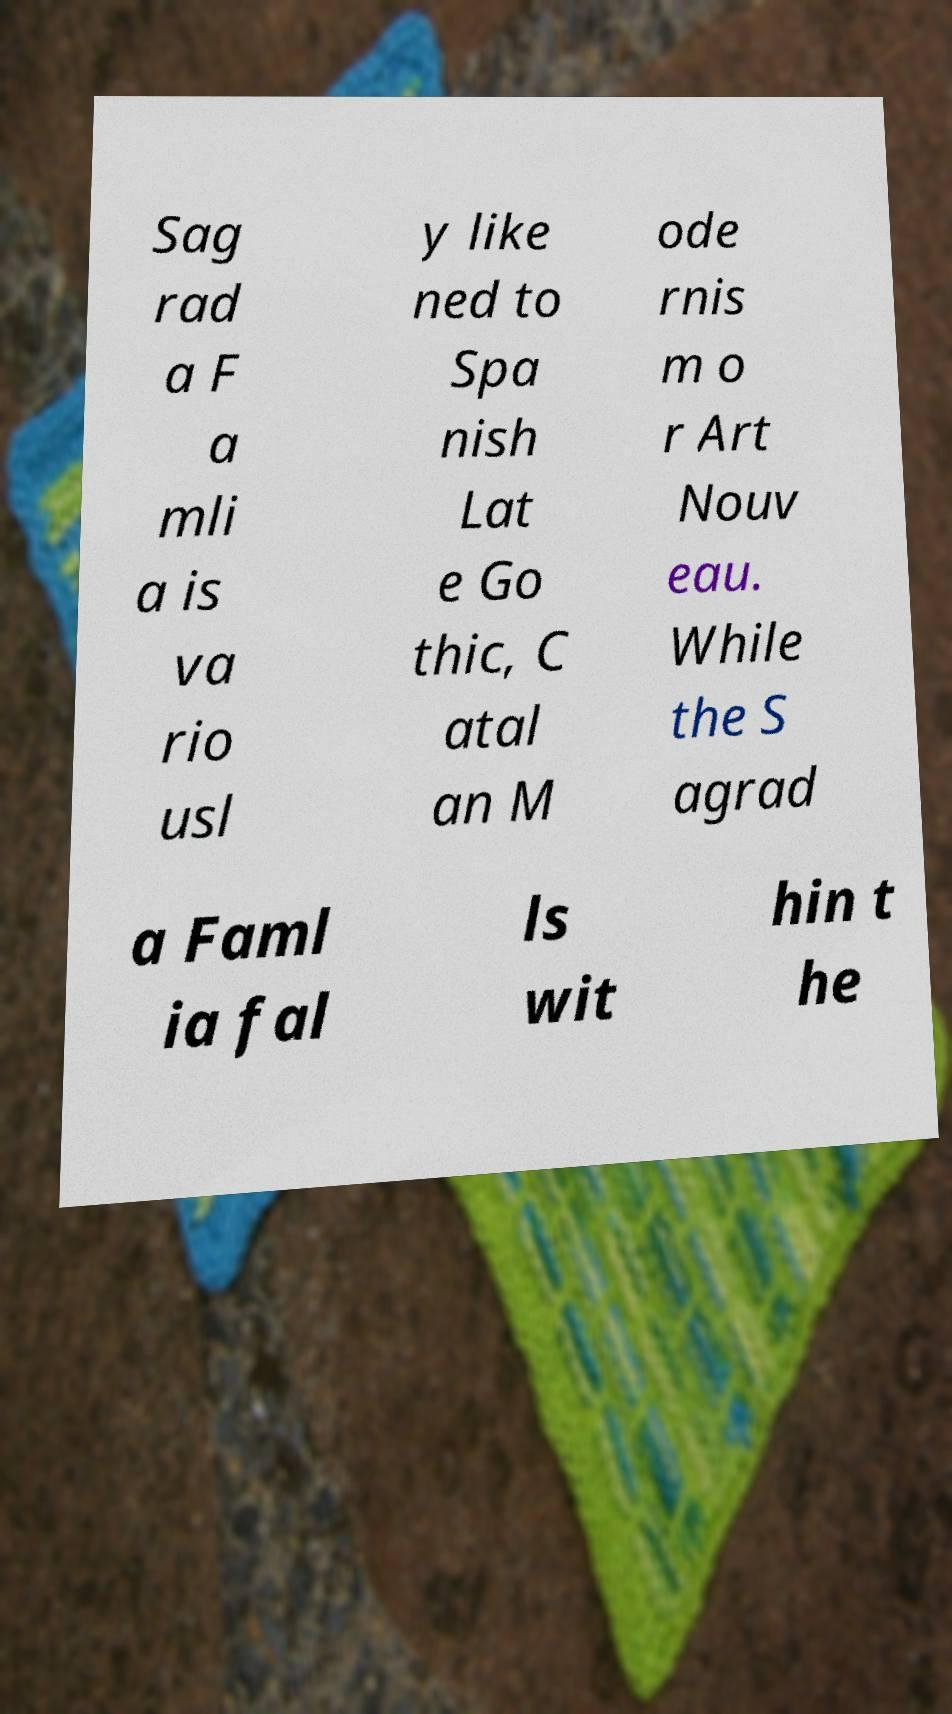Can you read and provide the text displayed in the image?This photo seems to have some interesting text. Can you extract and type it out for me? Sag rad a F a mli a is va rio usl y like ned to Spa nish Lat e Go thic, C atal an M ode rnis m o r Art Nouv eau. While the S agrad a Faml ia fal ls wit hin t he 